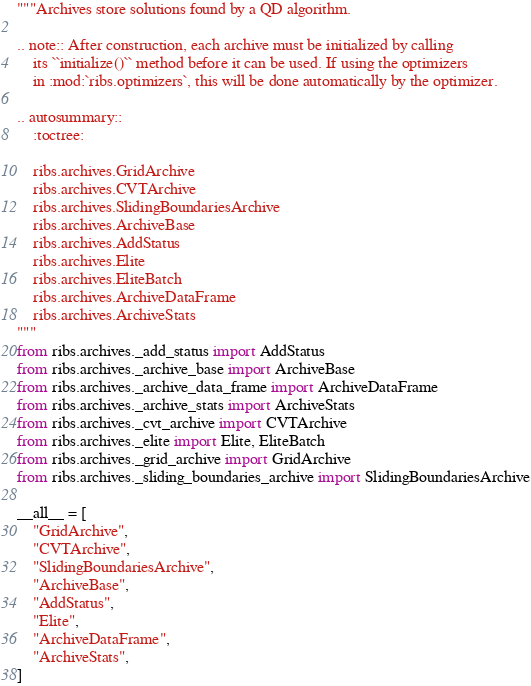<code> <loc_0><loc_0><loc_500><loc_500><_Python_>"""Archives store solutions found by a QD algorithm.

.. note:: After construction, each archive must be initialized by calling
    its ``initialize()`` method before it can be used. If using the optimizers
    in :mod:`ribs.optimizers`, this will be done automatically by the optimizer.

.. autosummary::
    :toctree:

    ribs.archives.GridArchive
    ribs.archives.CVTArchive
    ribs.archives.SlidingBoundariesArchive
    ribs.archives.ArchiveBase
    ribs.archives.AddStatus
    ribs.archives.Elite
    ribs.archives.EliteBatch
    ribs.archives.ArchiveDataFrame
    ribs.archives.ArchiveStats
"""
from ribs.archives._add_status import AddStatus
from ribs.archives._archive_base import ArchiveBase
from ribs.archives._archive_data_frame import ArchiveDataFrame
from ribs.archives._archive_stats import ArchiveStats
from ribs.archives._cvt_archive import CVTArchive
from ribs.archives._elite import Elite, EliteBatch
from ribs.archives._grid_archive import GridArchive
from ribs.archives._sliding_boundaries_archive import SlidingBoundariesArchive

__all__ = [
    "GridArchive",
    "CVTArchive",
    "SlidingBoundariesArchive",
    "ArchiveBase",
    "AddStatus",
    "Elite",
    "ArchiveDataFrame",
    "ArchiveStats",
]
</code> 